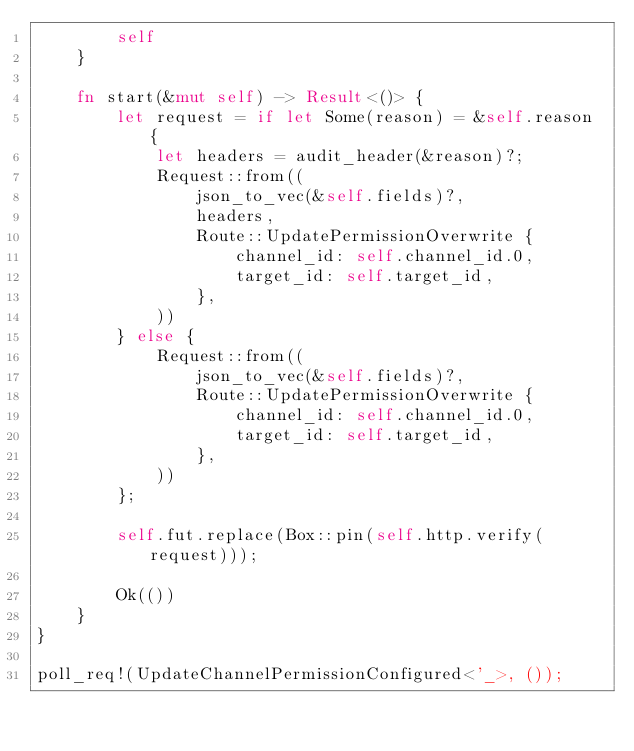Convert code to text. <code><loc_0><loc_0><loc_500><loc_500><_Rust_>        self
    }

    fn start(&mut self) -> Result<()> {
        let request = if let Some(reason) = &self.reason {
            let headers = audit_header(&reason)?;
            Request::from((
                json_to_vec(&self.fields)?,
                headers,
                Route::UpdatePermissionOverwrite {
                    channel_id: self.channel_id.0,
                    target_id: self.target_id,
                },
            ))
        } else {
            Request::from((
                json_to_vec(&self.fields)?,
                Route::UpdatePermissionOverwrite {
                    channel_id: self.channel_id.0,
                    target_id: self.target_id,
                },
            ))
        };

        self.fut.replace(Box::pin(self.http.verify(request)));

        Ok(())
    }
}

poll_req!(UpdateChannelPermissionConfigured<'_>, ());
</code> 